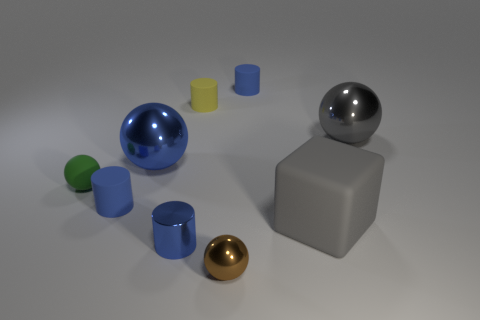Is the number of cubes less than the number of small brown matte spheres?
Offer a terse response. No. Are there any cubes that have the same material as the large blue thing?
Provide a succinct answer. No. There is a tiny green matte object; is it the same shape as the big object that is to the left of the gray rubber object?
Your answer should be very brief. Yes. There is a yellow cylinder; are there any gray metallic objects on the left side of it?
Make the answer very short. No. How many other big gray things are the same shape as the big matte object?
Your response must be concise. 0. Does the small brown ball have the same material as the blue cylinder that is behind the green rubber sphere?
Offer a terse response. No. How many blue metallic spheres are there?
Provide a succinct answer. 1. There is a cylinder that is behind the small yellow rubber cylinder; what size is it?
Offer a terse response. Small. What number of gray shiny balls have the same size as the blue metal cylinder?
Give a very brief answer. 0. What is the material of the blue cylinder that is behind the gray rubber object and in front of the small yellow rubber cylinder?
Offer a very short reply. Rubber. 